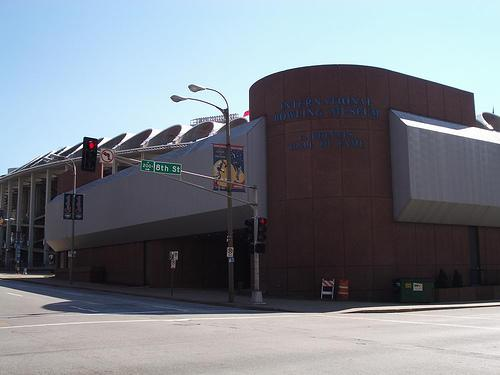Question: when was this photo taken?
Choices:
A. In the daytime.
B. In the evening.
C. In the morning.
D. In the afternoon.
Answer with the letter. Answer: A Question: where was this photo taken?
Choices:
A. On Sycamore Avenue.
B. On Wheatfield Drive.
C. On 11th Street.
D. On 8th street.
Answer with the letter. Answer: D 